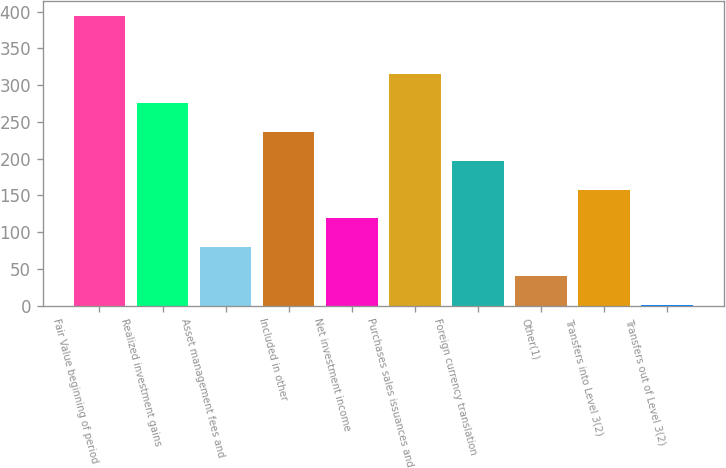Convert chart to OTSL. <chart><loc_0><loc_0><loc_500><loc_500><bar_chart><fcel>Fair Value beginning of period<fcel>Realized investment gains<fcel>Asset management fees and<fcel>Included in other<fcel>Net investment income<fcel>Purchases sales issuances and<fcel>Foreign currency translation<fcel>Other(1)<fcel>Transfers into Level 3(2)<fcel>Transfers out of Level 3(2)<nl><fcel>394.2<fcel>275.4<fcel>79.4<fcel>236.2<fcel>118.6<fcel>314.6<fcel>197<fcel>40.2<fcel>157.8<fcel>1<nl></chart> 